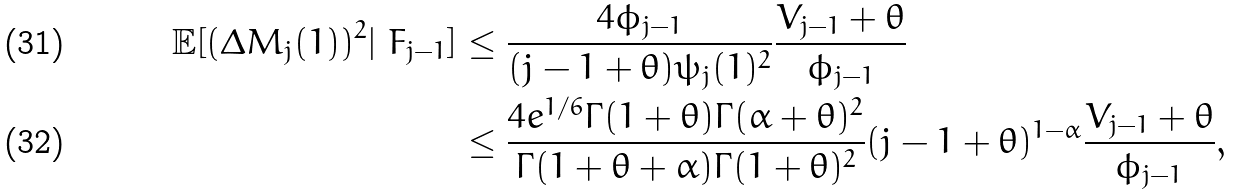<formula> <loc_0><loc_0><loc_500><loc_500>\mathbb { E } [ ( \Delta M _ { j } ( 1 ) ) ^ { 2 } | \ F _ { j - 1 } ] & \leq \frac { 4 \phi _ { j - 1 } } { ( j - 1 + \theta ) \psi _ { j } ( 1 ) ^ { 2 } } \frac { V _ { j - 1 } + \theta } { \phi _ { j - 1 } } \\ & \leq \frac { 4 e ^ { 1 / 6 } \Gamma ( 1 + \theta ) \Gamma ( \alpha + \theta ) ^ { 2 } } { \Gamma ( 1 + \theta + \alpha ) \Gamma ( 1 + \theta ) ^ { 2 } } ( j - 1 + \theta ) ^ { 1 - \alpha } \frac { V _ { j - 1 } + \theta } { \phi _ { j - 1 } } ,</formula> 